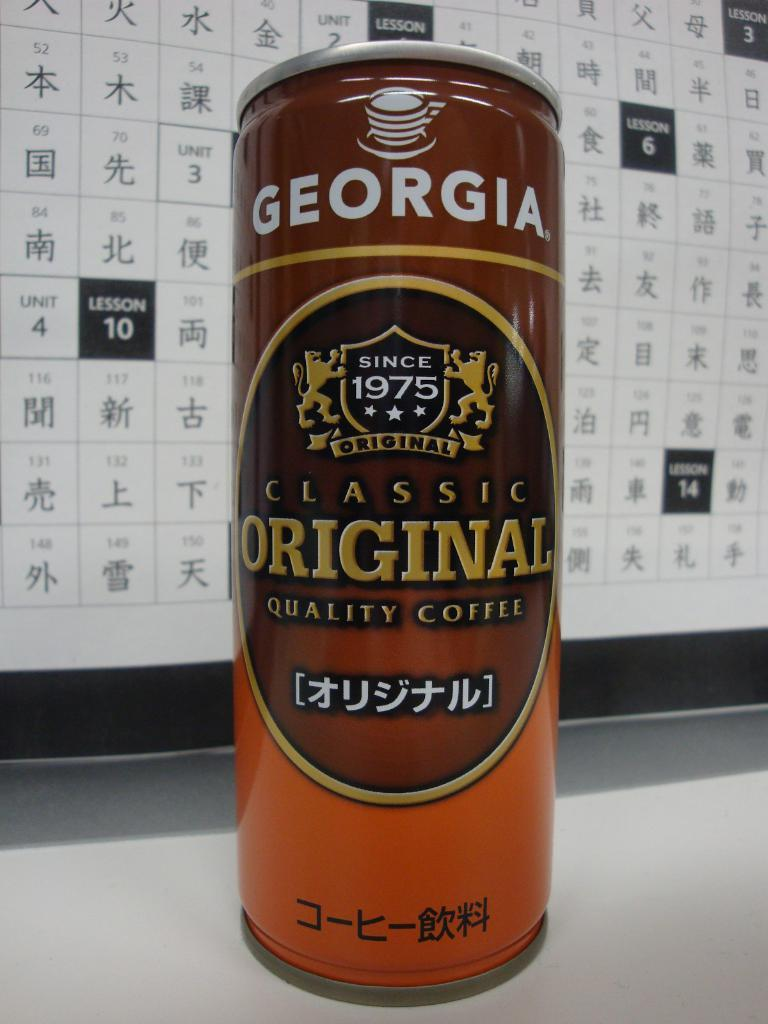<image>
Describe the image concisely. a can of georgia since 1975 original classic quality coffee 